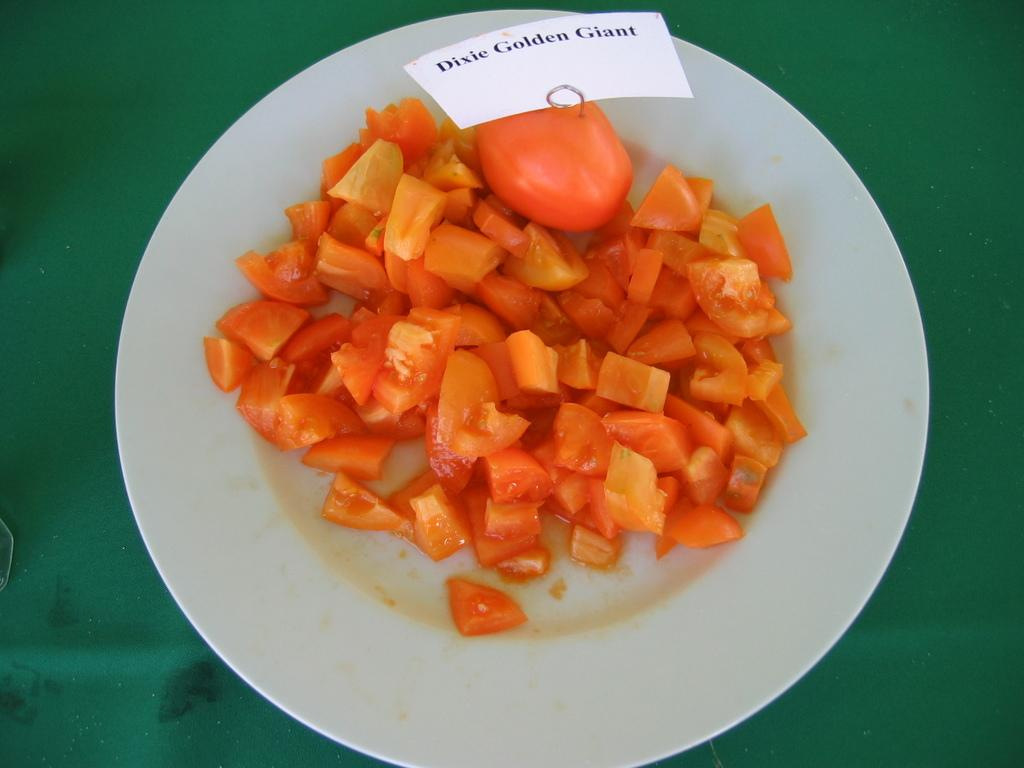What is on the plate that is visible in the image? The plate contains tomato pieces. Is there anything else on the plate besides the tomato pieces? Yes, there is a paper on the plate. What is the color of the cloth that the plate is placed on? The plate is placed on a green color cloth. What type of bird is having a discussion with the tomato pieces in the image? There is no bird present in the image, and therefore no discussion involving the tomato pieces can be observed. 